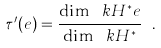Convert formula to latex. <formula><loc_0><loc_0><loc_500><loc_500>\tau ^ { \prime } ( e ) = \frac { \dim _ { \ } k H ^ { * } e } { \dim _ { \ } k H ^ { * } } \ .</formula> 